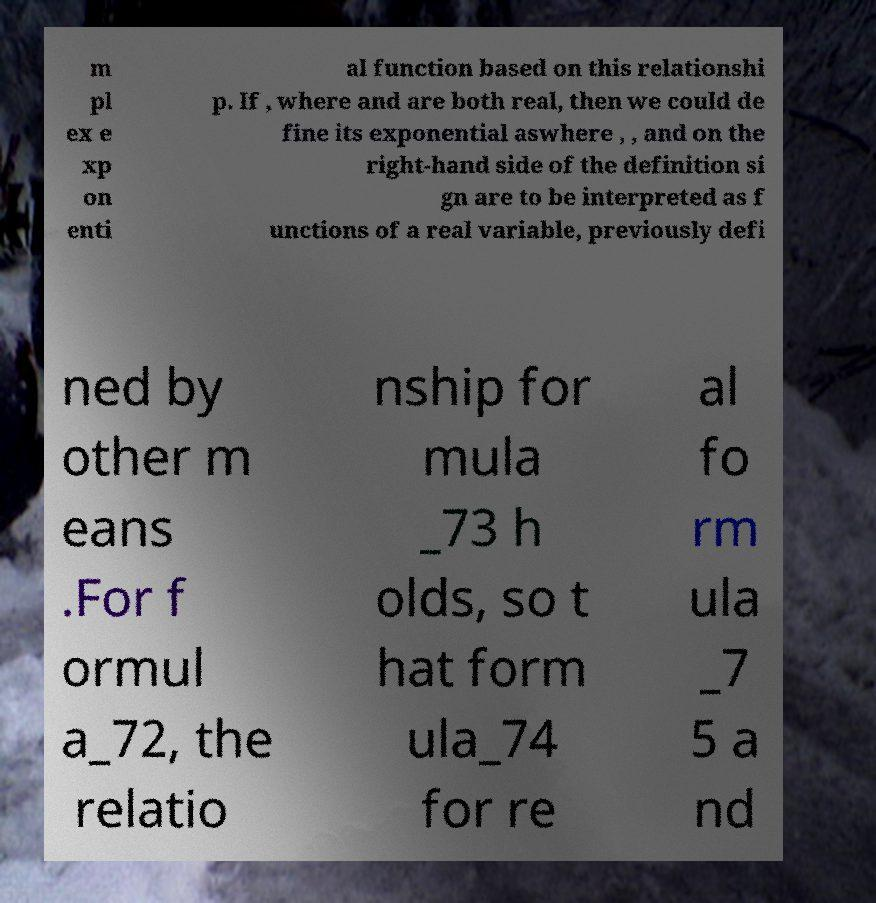What messages or text are displayed in this image? I need them in a readable, typed format. m pl ex e xp on enti al function based on this relationshi p. If , where and are both real, then we could de fine its exponential aswhere , , and on the right-hand side of the definition si gn are to be interpreted as f unctions of a real variable, previously defi ned by other m eans .For f ormul a_72, the relatio nship for mula _73 h olds, so t hat form ula_74 for re al fo rm ula _7 5 a nd 